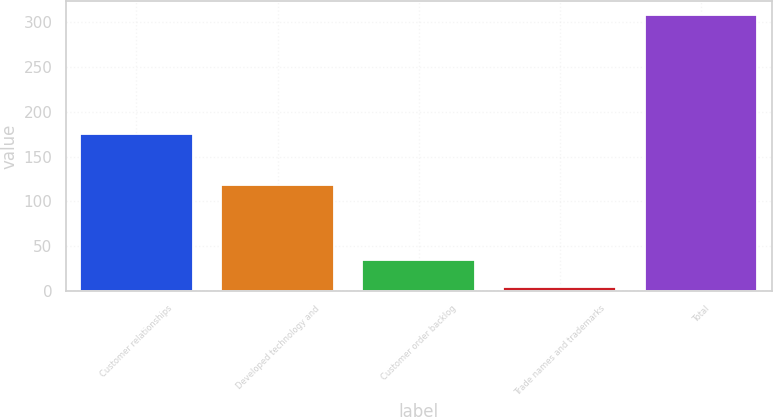<chart> <loc_0><loc_0><loc_500><loc_500><bar_chart><fcel>Customer relationships<fcel>Developed technology and<fcel>Customer order backlog<fcel>Trade names and trademarks<fcel>Total<nl><fcel>175<fcel>118<fcel>34.4<fcel>4<fcel>308<nl></chart> 